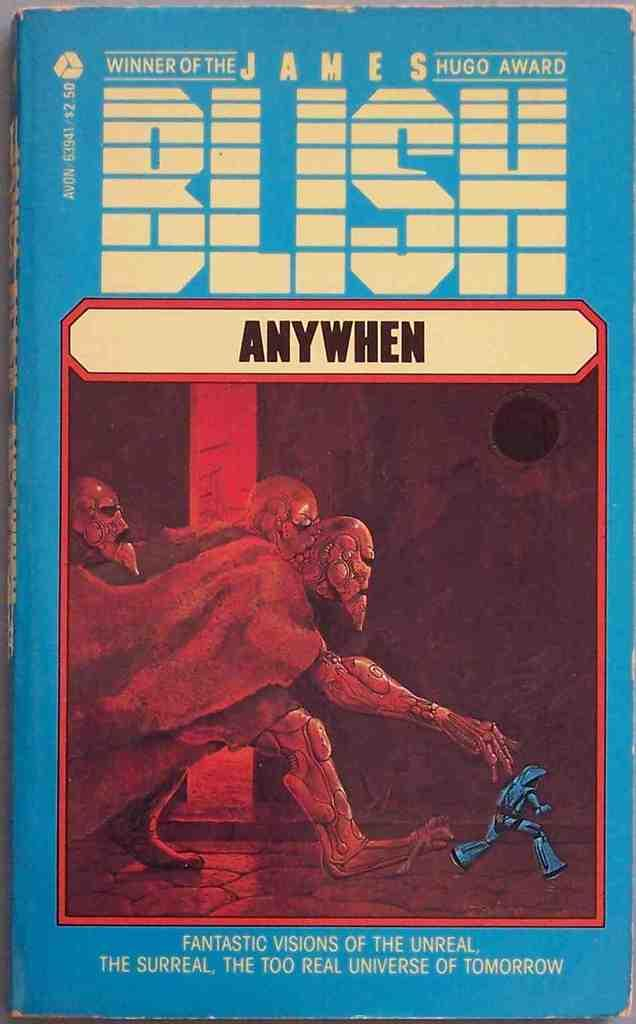<image>
Present a compact description of the photo's key features. Anywhen is a book by James Blish that won the James Hugo Award. 